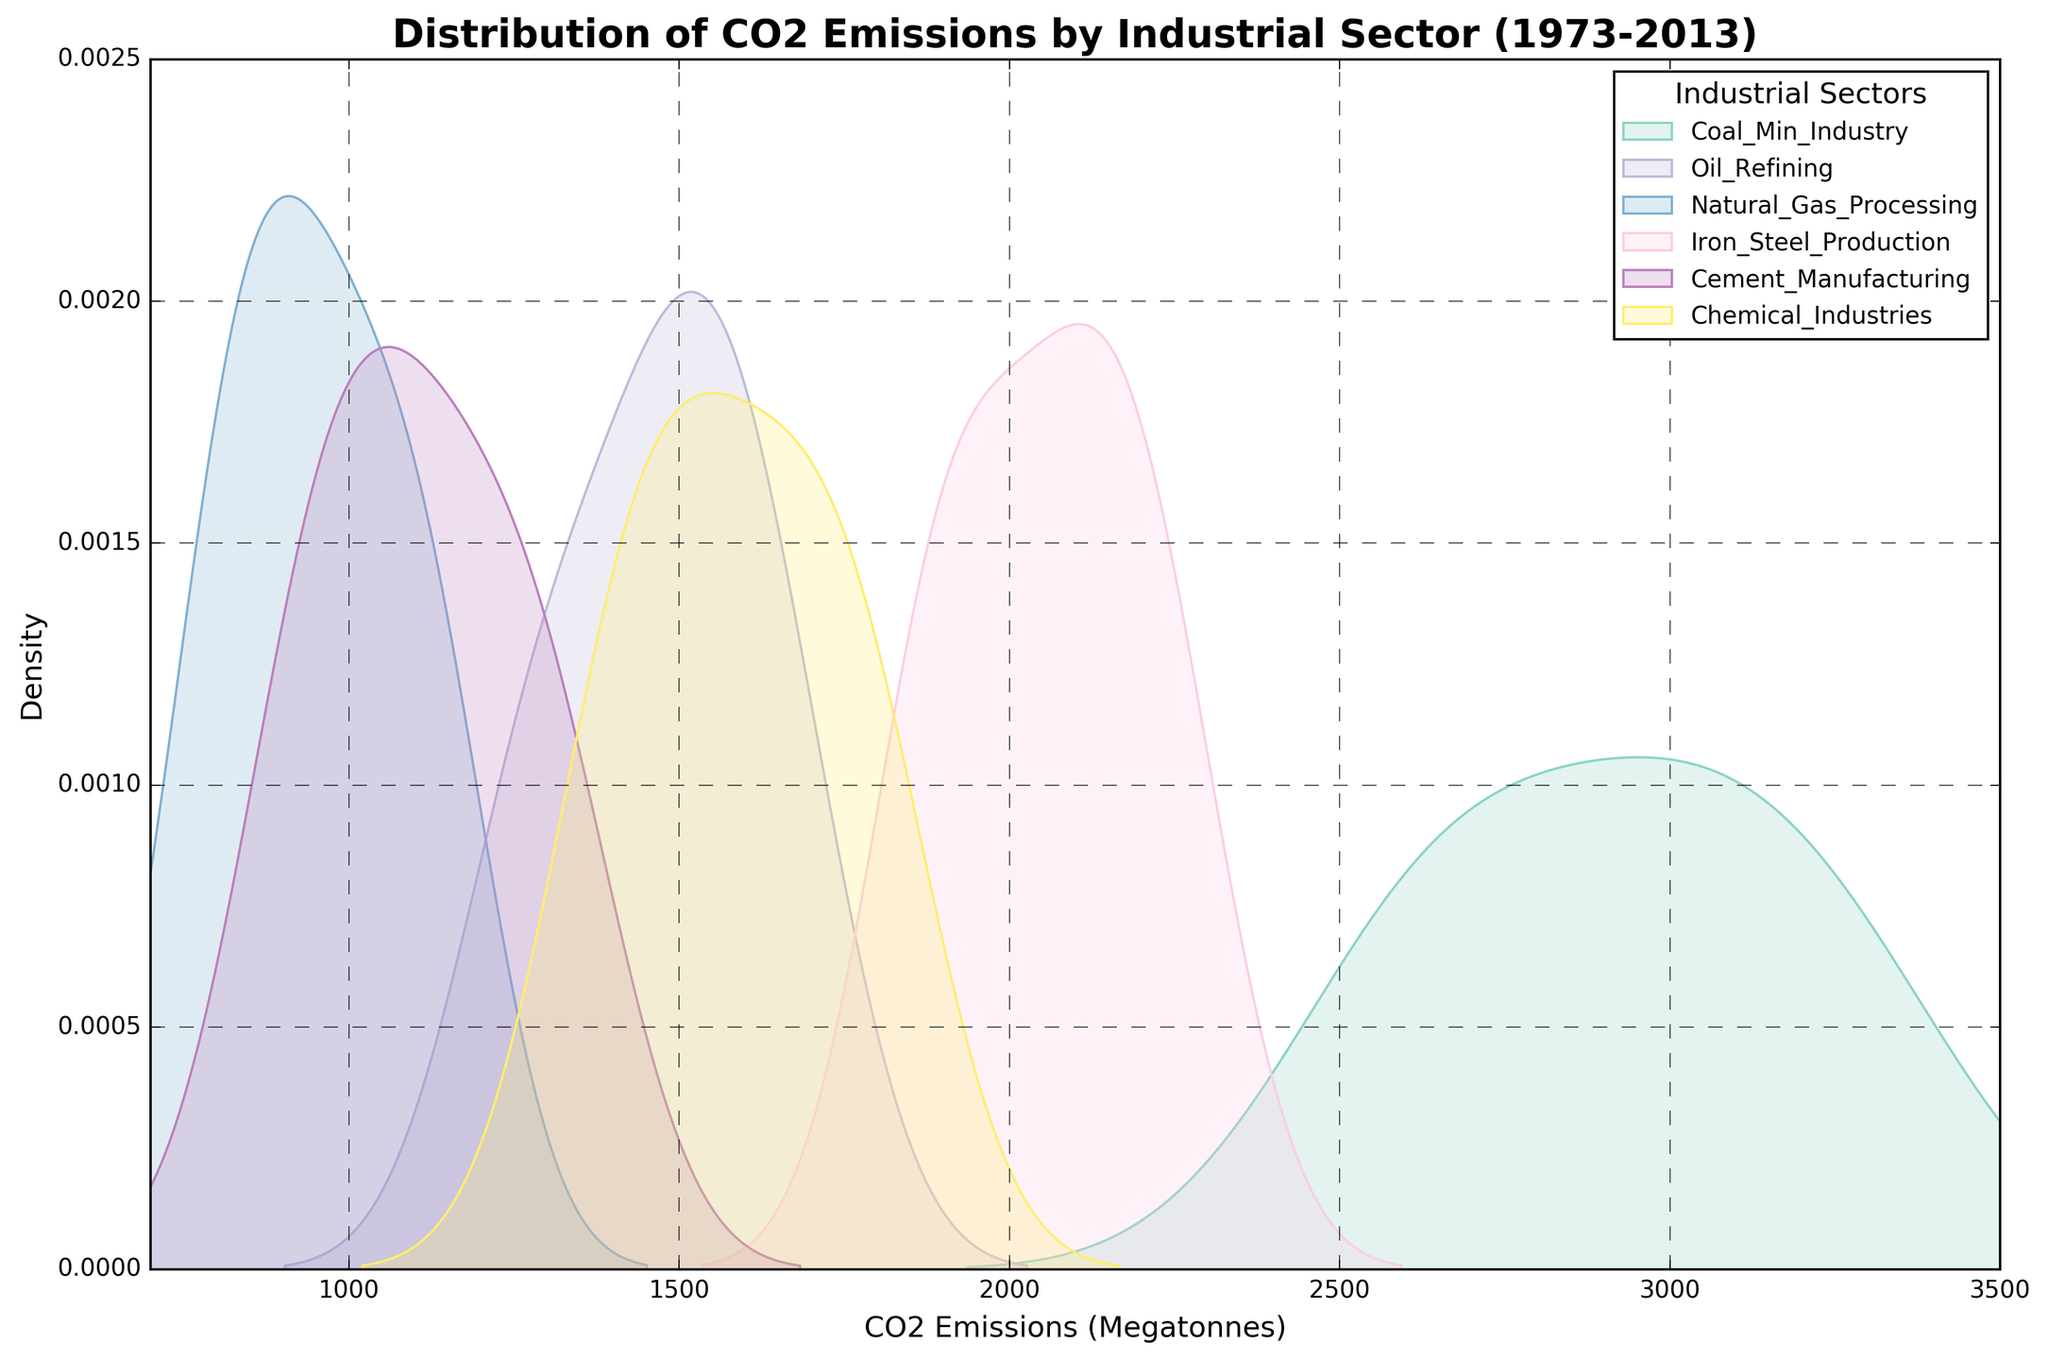What's the title of the figure? The title of a figure is typically found at the top of the plot and provides a summary of what the figure is about. In this case, it is provided at the top of the rendered figure.
Answer: Distribution of CO2 Emissions by Industrial Sector (1973-2013) What are the units used for CO2 emissions on the x-axis? The units for CO2 emissions can be found on the x-axis label. In this case, it specifies the units as "Megatonnes."
Answer: Megatonnes Which sector shows the highest density peak for CO2 emissions? To determine the sector with the highest density peak, observe the peak heights of each sector's density plot. The sector with the tallest peak has the highest density of emissions values.
Answer: Coal Min Industry Which sector has the lowest range of CO2 emissions? The sector with the lowest range of CO2 emissions can be identified by observing the span on the x-axis that each sector's plot covers. The sector with the narrowest spread has the lowest range.
Answer: Natural Gas Processing Which sectors have overlapping distributions in CO2 emissions? To identify sectors with overlapping distributions, look for sectors whose density plots intersect or cover similar ranges on the x-axis. The overlapping regions indicate overlapping distributions.
Answer: Oil Refining, Iron & Steel Production, Cement Manufacturing, Chemical Industries What is the approximate range of CO2 emissions for Iron & Steel Production? To determine the range, look at where the density plot for Iron & Steel Production starts and ends on the x-axis. Note the approximate endpoints.
Answer: 1875 to 2255 Megatonnes How does the CO2 emission distribution for Cement Manufacturing compare to that of Iron & Steel Production? Compare the density plots of Cement Manufacturing and Iron & Steel Production. Notice differences in the spread, peaks, and position along the x-axis. Cement Manufacturing shows a lower peak and narrower spread than Iron & Steel Production.
Answer: Cement Manufacturing has a narrower spread and a lower peak Which sector has the most concentrated CO2 emissions distribution? A concentrated distribution would have a higher peak and a narrower spread along the x-axis. By examining the density plot with these characteristics, we can determine that Natural Gas Processing has the most concentrated distribution.
Answer: Natural Gas Processing What can be inferred about the trend of CO2 emissions over the years for each sector? Observing the density plots of each sector, look at whether the distributions have peaks at higher emission values over time, suggesting an increase. For most sectors, the distribution peaks shift towards higher values, indicating an increase in CO2 emissions over the years.
Answer: Most sectors show increasing CO2 emissions over time 